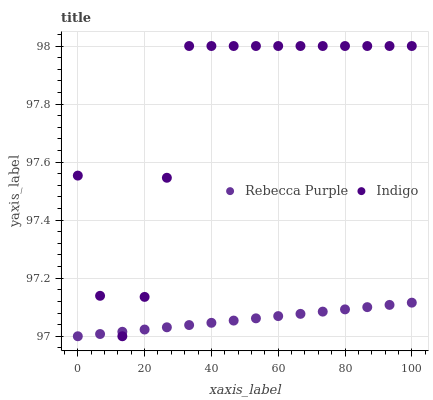Does Rebecca Purple have the minimum area under the curve?
Answer yes or no. Yes. Does Indigo have the maximum area under the curve?
Answer yes or no. Yes. Does Rebecca Purple have the maximum area under the curve?
Answer yes or no. No. Is Rebecca Purple the smoothest?
Answer yes or no. Yes. Is Indigo the roughest?
Answer yes or no. Yes. Is Rebecca Purple the roughest?
Answer yes or no. No. Does Rebecca Purple have the lowest value?
Answer yes or no. Yes. Does Indigo have the highest value?
Answer yes or no. Yes. Does Rebecca Purple have the highest value?
Answer yes or no. No. Does Indigo intersect Rebecca Purple?
Answer yes or no. Yes. Is Indigo less than Rebecca Purple?
Answer yes or no. No. Is Indigo greater than Rebecca Purple?
Answer yes or no. No. 